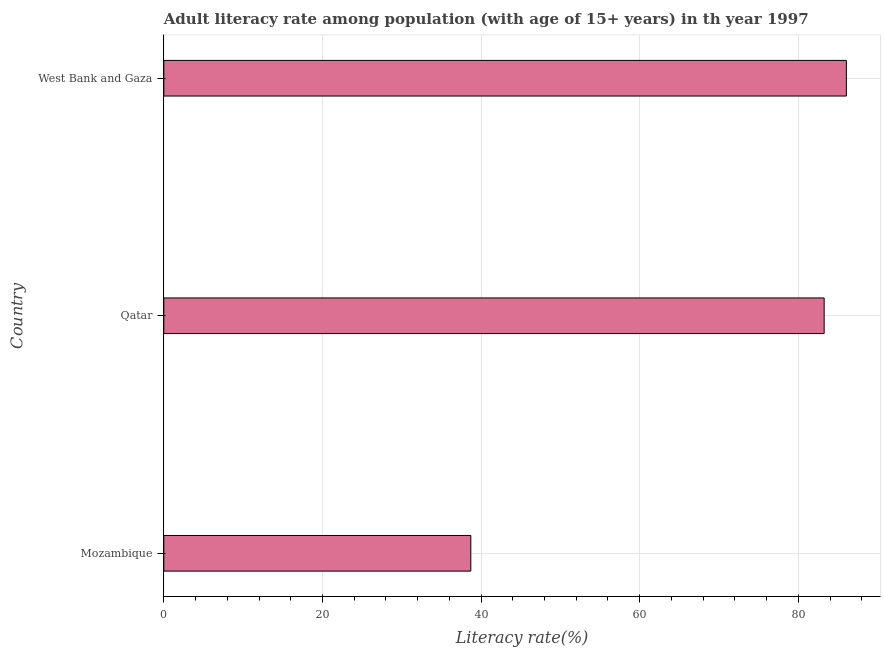Does the graph contain any zero values?
Make the answer very short. No. What is the title of the graph?
Your response must be concise. Adult literacy rate among population (with age of 15+ years) in th year 1997. What is the label or title of the X-axis?
Your response must be concise. Literacy rate(%). What is the label or title of the Y-axis?
Offer a terse response. Country. What is the adult literacy rate in West Bank and Gaza?
Your answer should be compact. 86.06. Across all countries, what is the maximum adult literacy rate?
Your response must be concise. 86.06. Across all countries, what is the minimum adult literacy rate?
Provide a succinct answer. 38.71. In which country was the adult literacy rate maximum?
Provide a short and direct response. West Bank and Gaza. In which country was the adult literacy rate minimum?
Ensure brevity in your answer.  Mozambique. What is the sum of the adult literacy rate?
Your response must be concise. 208.03. What is the difference between the adult literacy rate in Qatar and West Bank and Gaza?
Keep it short and to the point. -2.8. What is the average adult literacy rate per country?
Your response must be concise. 69.34. What is the median adult literacy rate?
Your response must be concise. 83.26. In how many countries, is the adult literacy rate greater than 84 %?
Offer a terse response. 1. What is the ratio of the adult literacy rate in Mozambique to that in West Bank and Gaza?
Make the answer very short. 0.45. Is the adult literacy rate in Qatar less than that in West Bank and Gaza?
Provide a succinct answer. Yes. What is the difference between the highest and the second highest adult literacy rate?
Give a very brief answer. 2.8. Is the sum of the adult literacy rate in Mozambique and Qatar greater than the maximum adult literacy rate across all countries?
Your response must be concise. Yes. What is the difference between the highest and the lowest adult literacy rate?
Your response must be concise. 47.36. How many bars are there?
Make the answer very short. 3. Are all the bars in the graph horizontal?
Your answer should be very brief. Yes. How many countries are there in the graph?
Keep it short and to the point. 3. Are the values on the major ticks of X-axis written in scientific E-notation?
Offer a very short reply. No. What is the Literacy rate(%) of Mozambique?
Your answer should be very brief. 38.71. What is the Literacy rate(%) of Qatar?
Offer a very short reply. 83.26. What is the Literacy rate(%) of West Bank and Gaza?
Your answer should be very brief. 86.06. What is the difference between the Literacy rate(%) in Mozambique and Qatar?
Ensure brevity in your answer.  -44.55. What is the difference between the Literacy rate(%) in Mozambique and West Bank and Gaza?
Offer a very short reply. -47.36. What is the difference between the Literacy rate(%) in Qatar and West Bank and Gaza?
Offer a terse response. -2.8. What is the ratio of the Literacy rate(%) in Mozambique to that in Qatar?
Your response must be concise. 0.47. What is the ratio of the Literacy rate(%) in Mozambique to that in West Bank and Gaza?
Your answer should be very brief. 0.45. What is the ratio of the Literacy rate(%) in Qatar to that in West Bank and Gaza?
Provide a succinct answer. 0.97. 